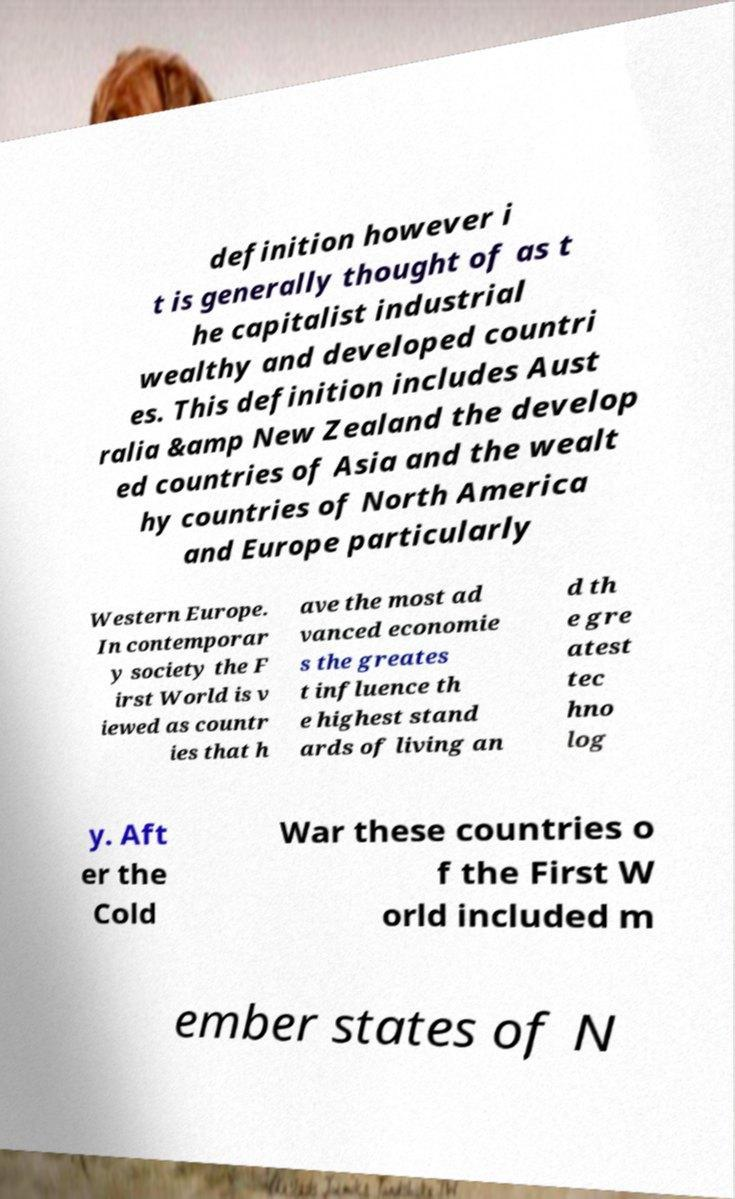What messages or text are displayed in this image? I need them in a readable, typed format. definition however i t is generally thought of as t he capitalist industrial wealthy and developed countri es. This definition includes Aust ralia &amp New Zealand the develop ed countries of Asia and the wealt hy countries of North America and Europe particularly Western Europe. In contemporar y society the F irst World is v iewed as countr ies that h ave the most ad vanced economie s the greates t influence th e highest stand ards of living an d th e gre atest tec hno log y. Aft er the Cold War these countries o f the First W orld included m ember states of N 